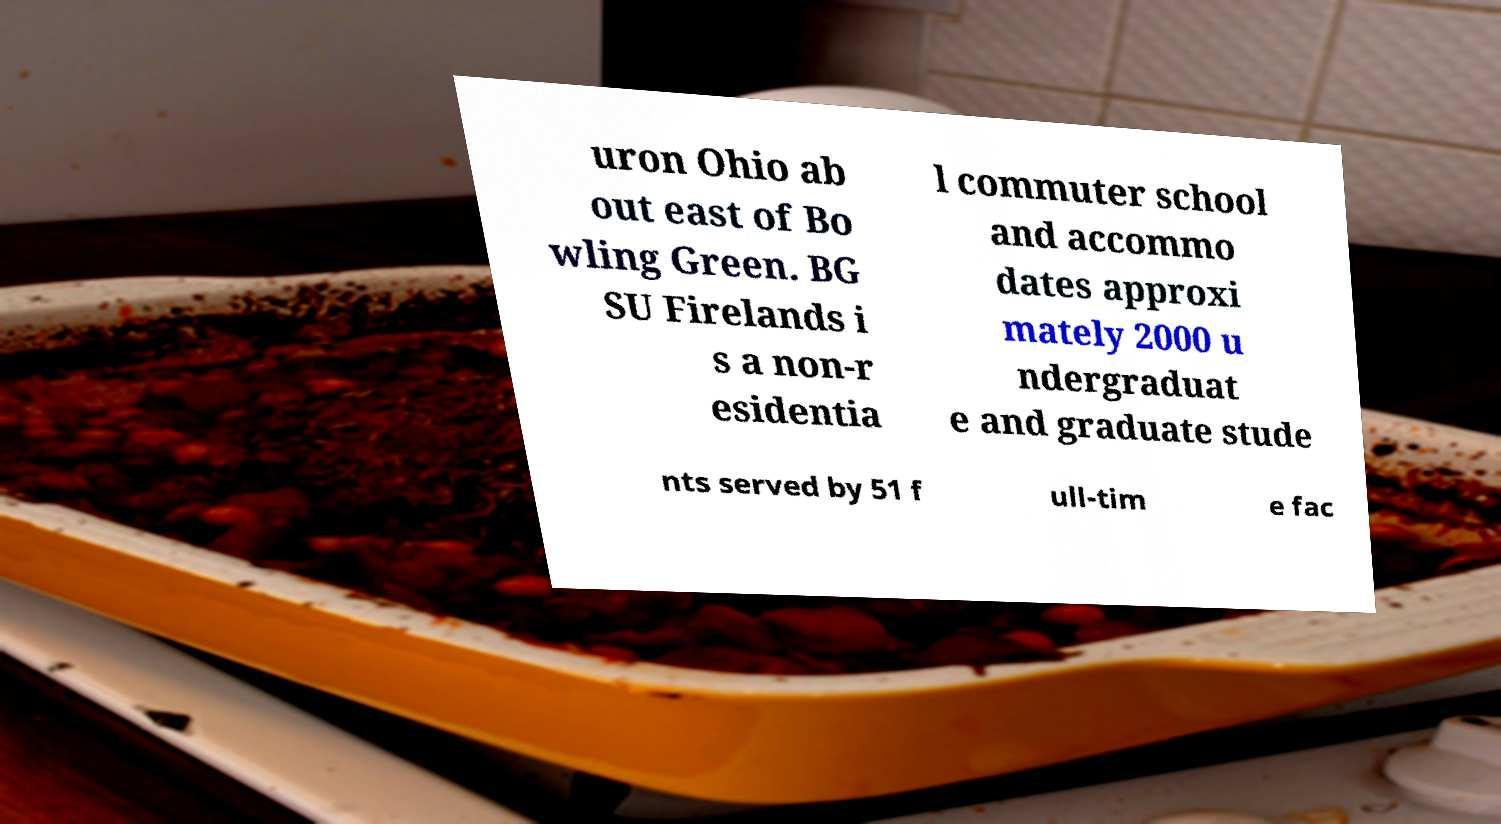Could you assist in decoding the text presented in this image and type it out clearly? uron Ohio ab out east of Bo wling Green. BG SU Firelands i s a non-r esidentia l commuter school and accommo dates approxi mately 2000 u ndergraduat e and graduate stude nts served by 51 f ull-tim e fac 